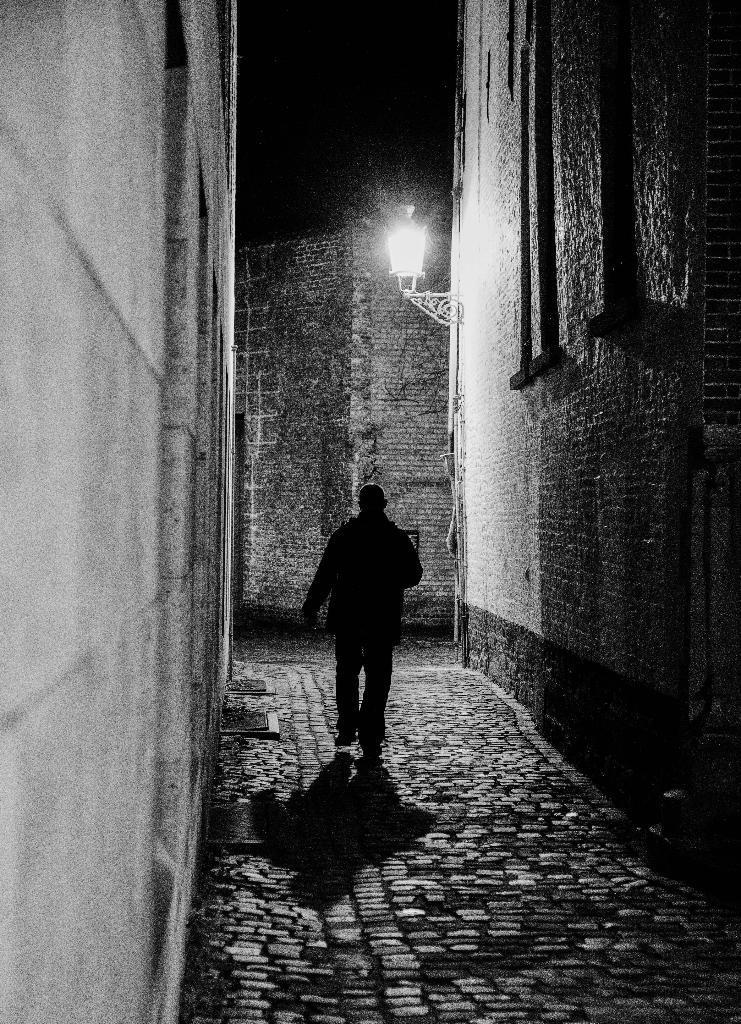In one or two sentences, can you explain what this image depicts? In this picture there is a man walking in the lane and cobbler stones on the ground. On both the side there is a granite wall and in the front there is a lamppost. 